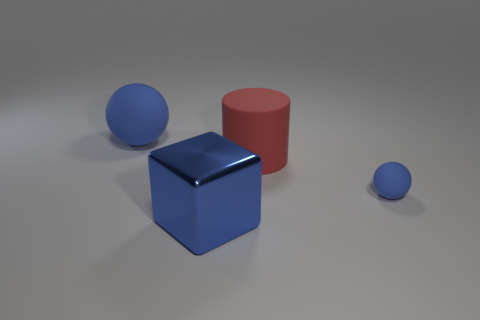Add 4 tiny things. How many objects exist? 8 Subtract all cylinders. How many objects are left? 3 Add 3 large cylinders. How many large cylinders are left? 4 Add 3 blue objects. How many blue objects exist? 6 Subtract 0 red balls. How many objects are left? 4 Subtract all small blue objects. Subtract all blue rubber balls. How many objects are left? 1 